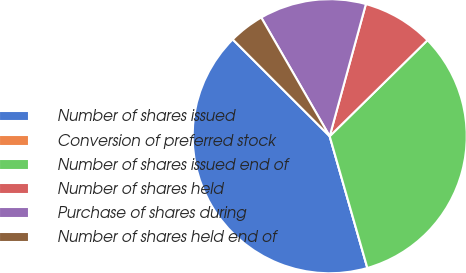Convert chart to OTSL. <chart><loc_0><loc_0><loc_500><loc_500><pie_chart><fcel>Number of shares issued<fcel>Conversion of preferred stock<fcel>Number of shares issued end of<fcel>Number of shares held<fcel>Purchase of shares during<fcel>Number of shares held end of<nl><fcel>41.92%<fcel>0.0%<fcel>32.92%<fcel>8.39%<fcel>12.58%<fcel>4.19%<nl></chart> 